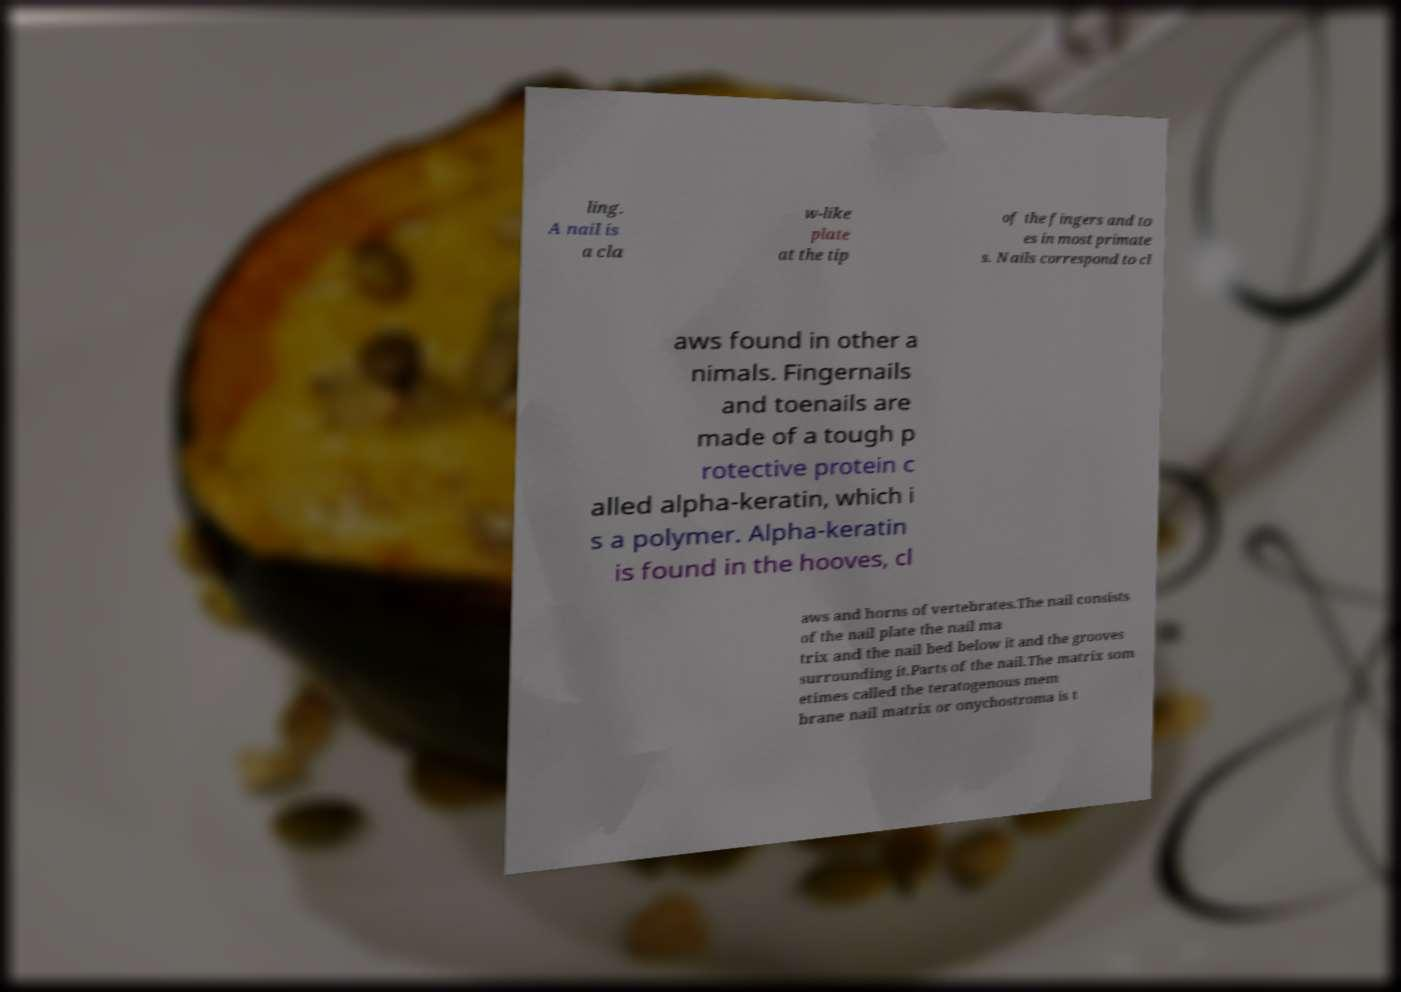There's text embedded in this image that I need extracted. Can you transcribe it verbatim? ling. A nail is a cla w-like plate at the tip of the fingers and to es in most primate s. Nails correspond to cl aws found in other a nimals. Fingernails and toenails are made of a tough p rotective protein c alled alpha-keratin, which i s a polymer. Alpha-keratin is found in the hooves, cl aws and horns of vertebrates.The nail consists of the nail plate the nail ma trix and the nail bed below it and the grooves surrounding it.Parts of the nail.The matrix som etimes called the teratogenous mem brane nail matrix or onychostroma is t 